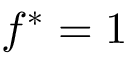Convert formula to latex. <formula><loc_0><loc_0><loc_500><loc_500>f ^ { * } = 1</formula> 